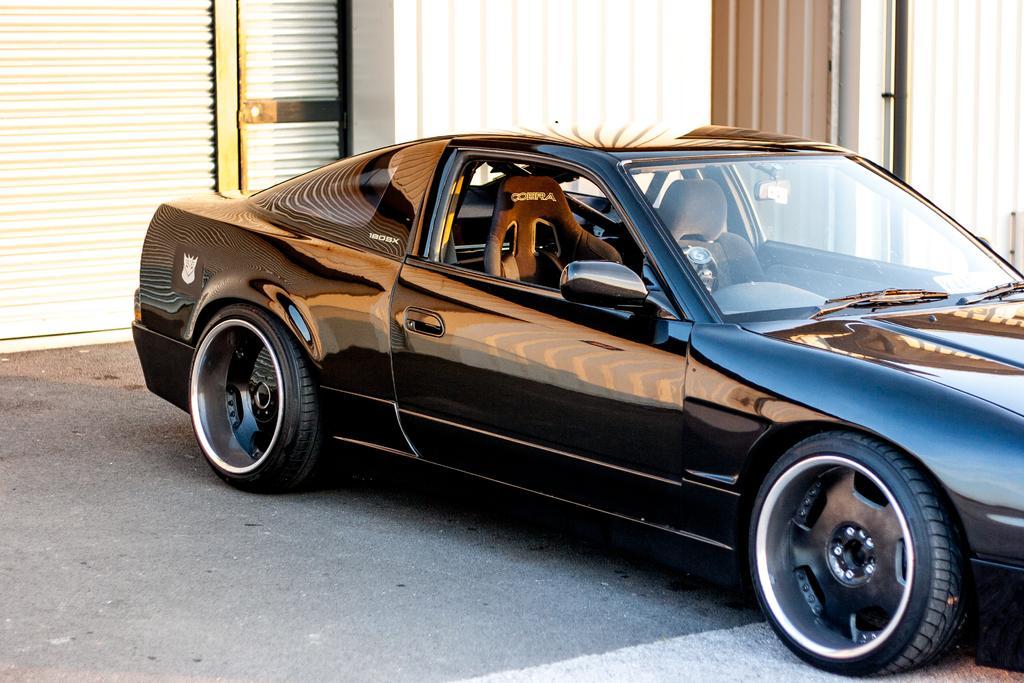In one or two sentences, can you explain what this image depicts? In this image we can see a black color car is parked on the road. In the background, we can see shutters and the wall. 